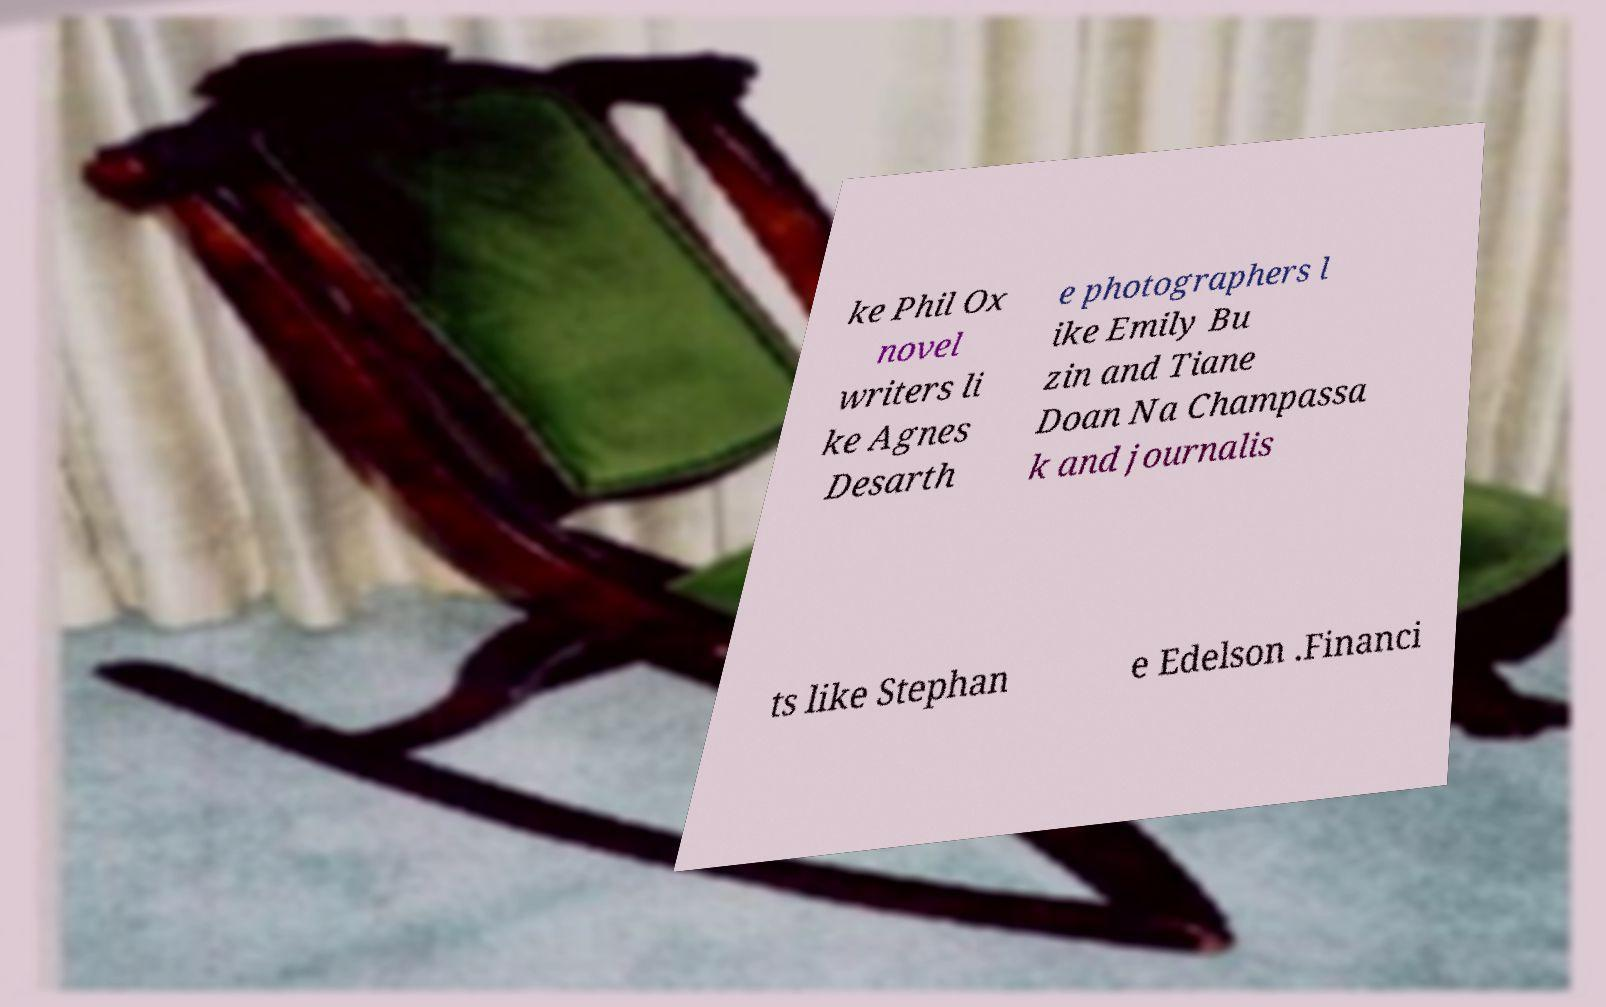Can you accurately transcribe the text from the provided image for me? ke Phil Ox novel writers li ke Agnes Desarth e photographers l ike Emily Bu zin and Tiane Doan Na Champassa k and journalis ts like Stephan e Edelson .Financi 